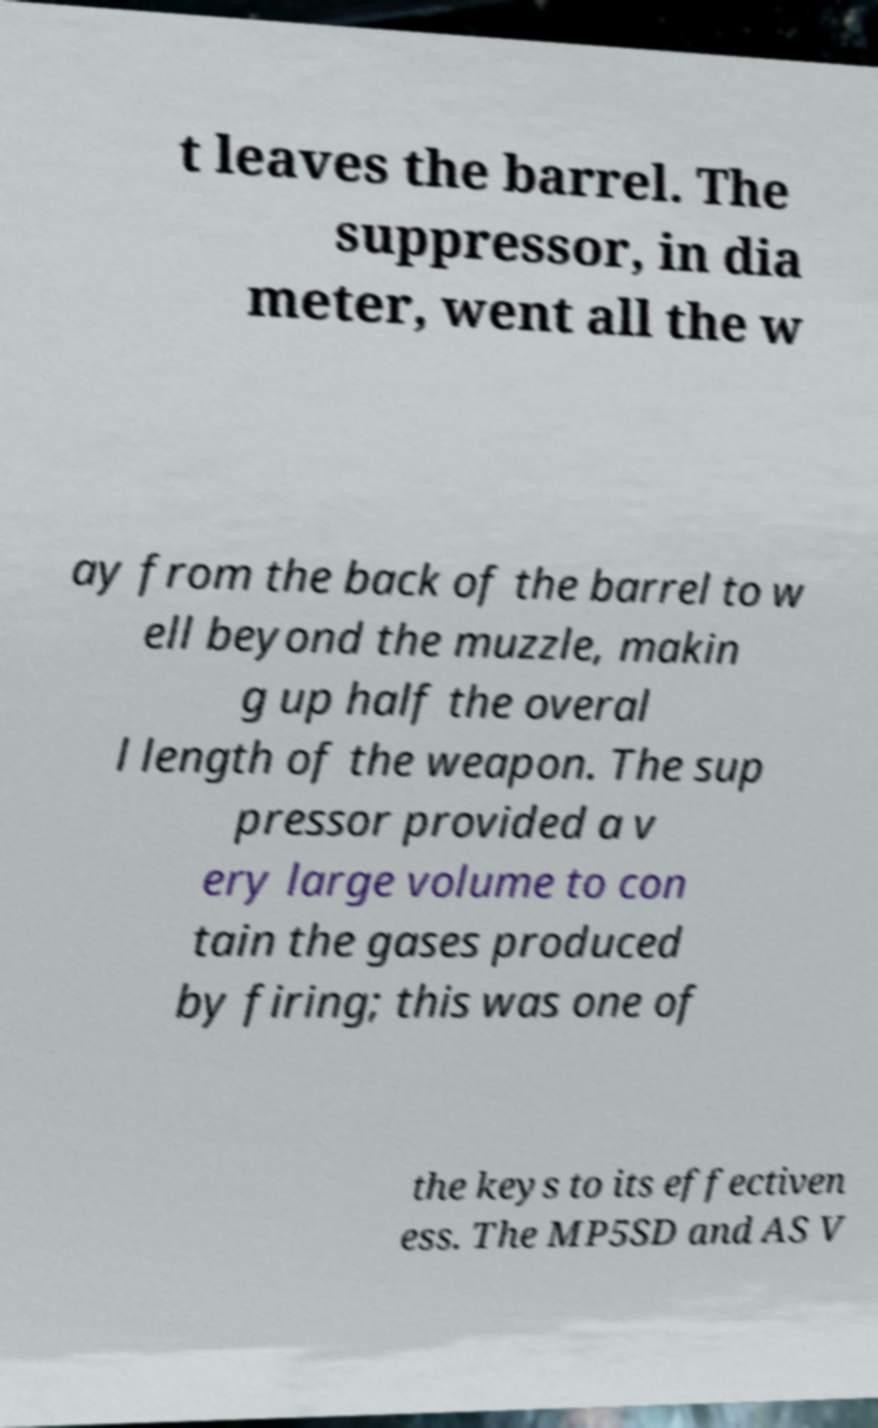Please identify and transcribe the text found in this image. t leaves the barrel. The suppressor, in dia meter, went all the w ay from the back of the barrel to w ell beyond the muzzle, makin g up half the overal l length of the weapon. The sup pressor provided a v ery large volume to con tain the gases produced by firing; this was one of the keys to its effectiven ess. The MP5SD and AS V 